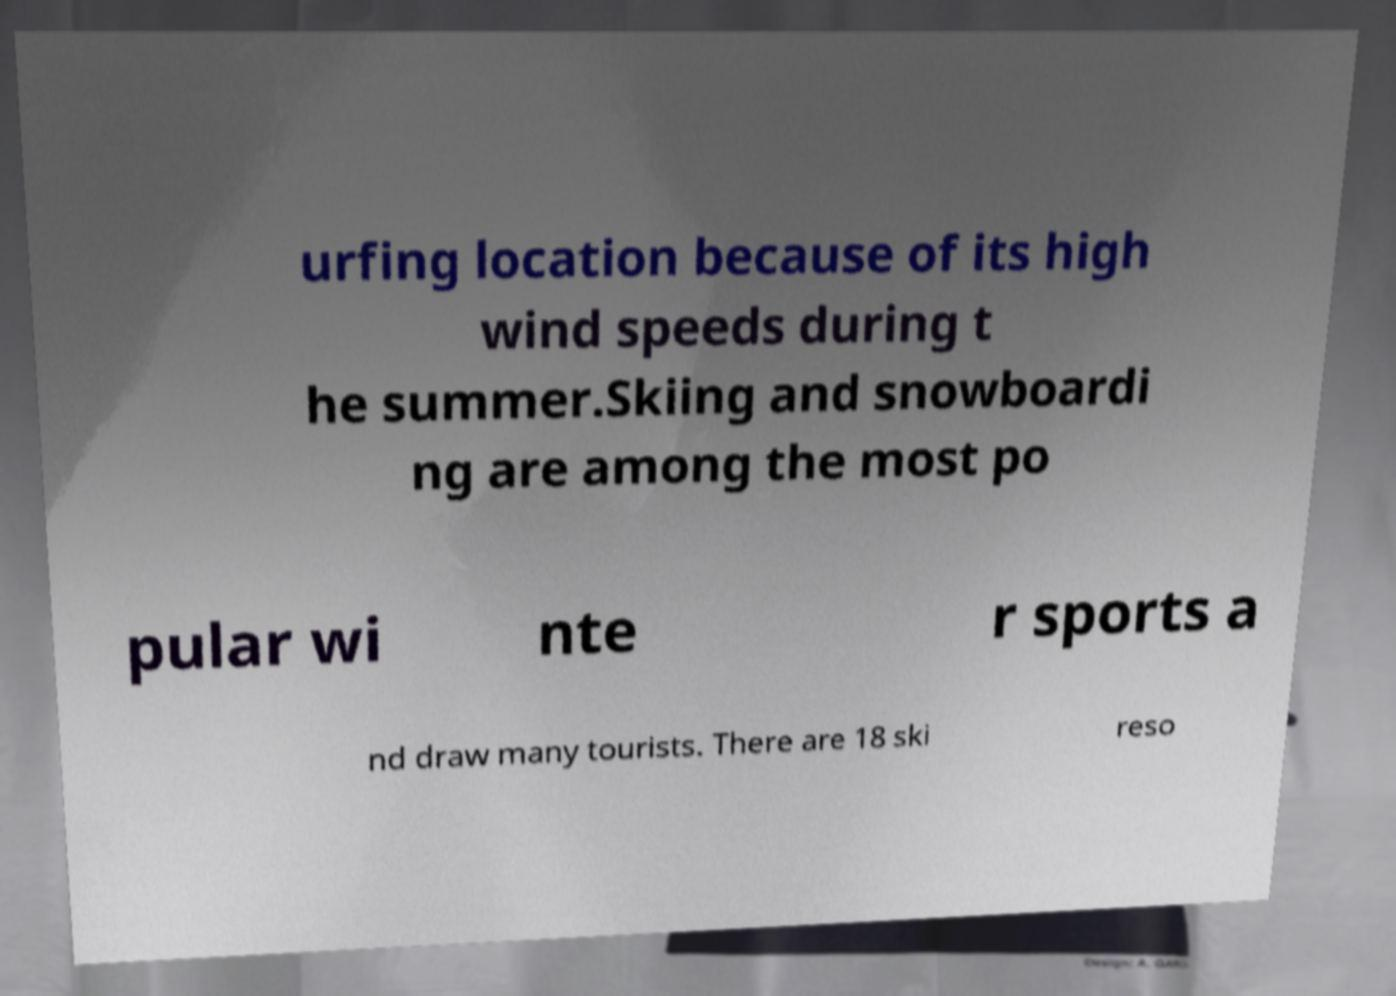Please identify and transcribe the text found in this image. urfing location because of its high wind speeds during t he summer.Skiing and snowboardi ng are among the most po pular wi nte r sports a nd draw many tourists. There are 18 ski reso 